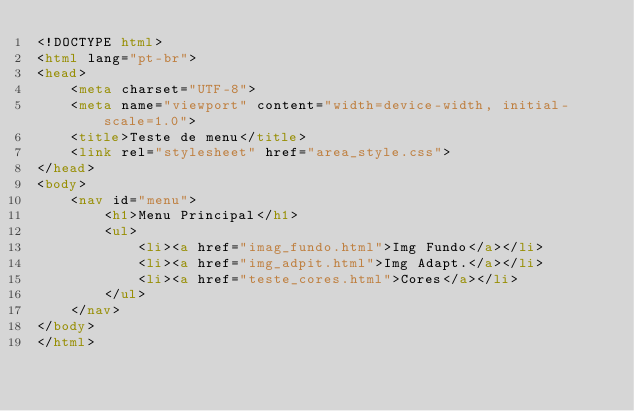Convert code to text. <code><loc_0><loc_0><loc_500><loc_500><_HTML_><!DOCTYPE html>
<html lang="pt-br">
<head>
    <meta charset="UTF-8">
    <meta name="viewport" content="width=device-width, initial-scale=1.0">
    <title>Teste de menu</title>
    <link rel="stylesheet" href="area_style.css">
</head>
<body>
    <nav id="menu">
        <h1>Menu Principal</h1>
        <ul>
            <li><a href="imag_fundo.html">Img Fundo</a></li>
            <li><a href="img_adpit.html">Img Adapt.</a></li>
            <li><a href="teste_cores.html">Cores</a></li>
        </ul>
    </nav>
</body>
</html></code> 